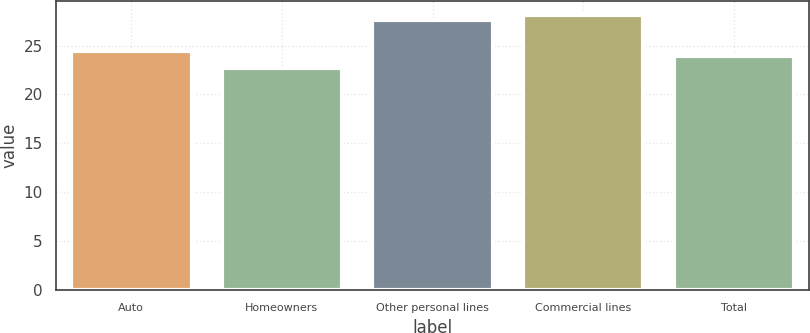<chart> <loc_0><loc_0><loc_500><loc_500><bar_chart><fcel>Auto<fcel>Homeowners<fcel>Other personal lines<fcel>Commercial lines<fcel>Total<nl><fcel>24.41<fcel>22.7<fcel>27.6<fcel>28.11<fcel>23.9<nl></chart> 